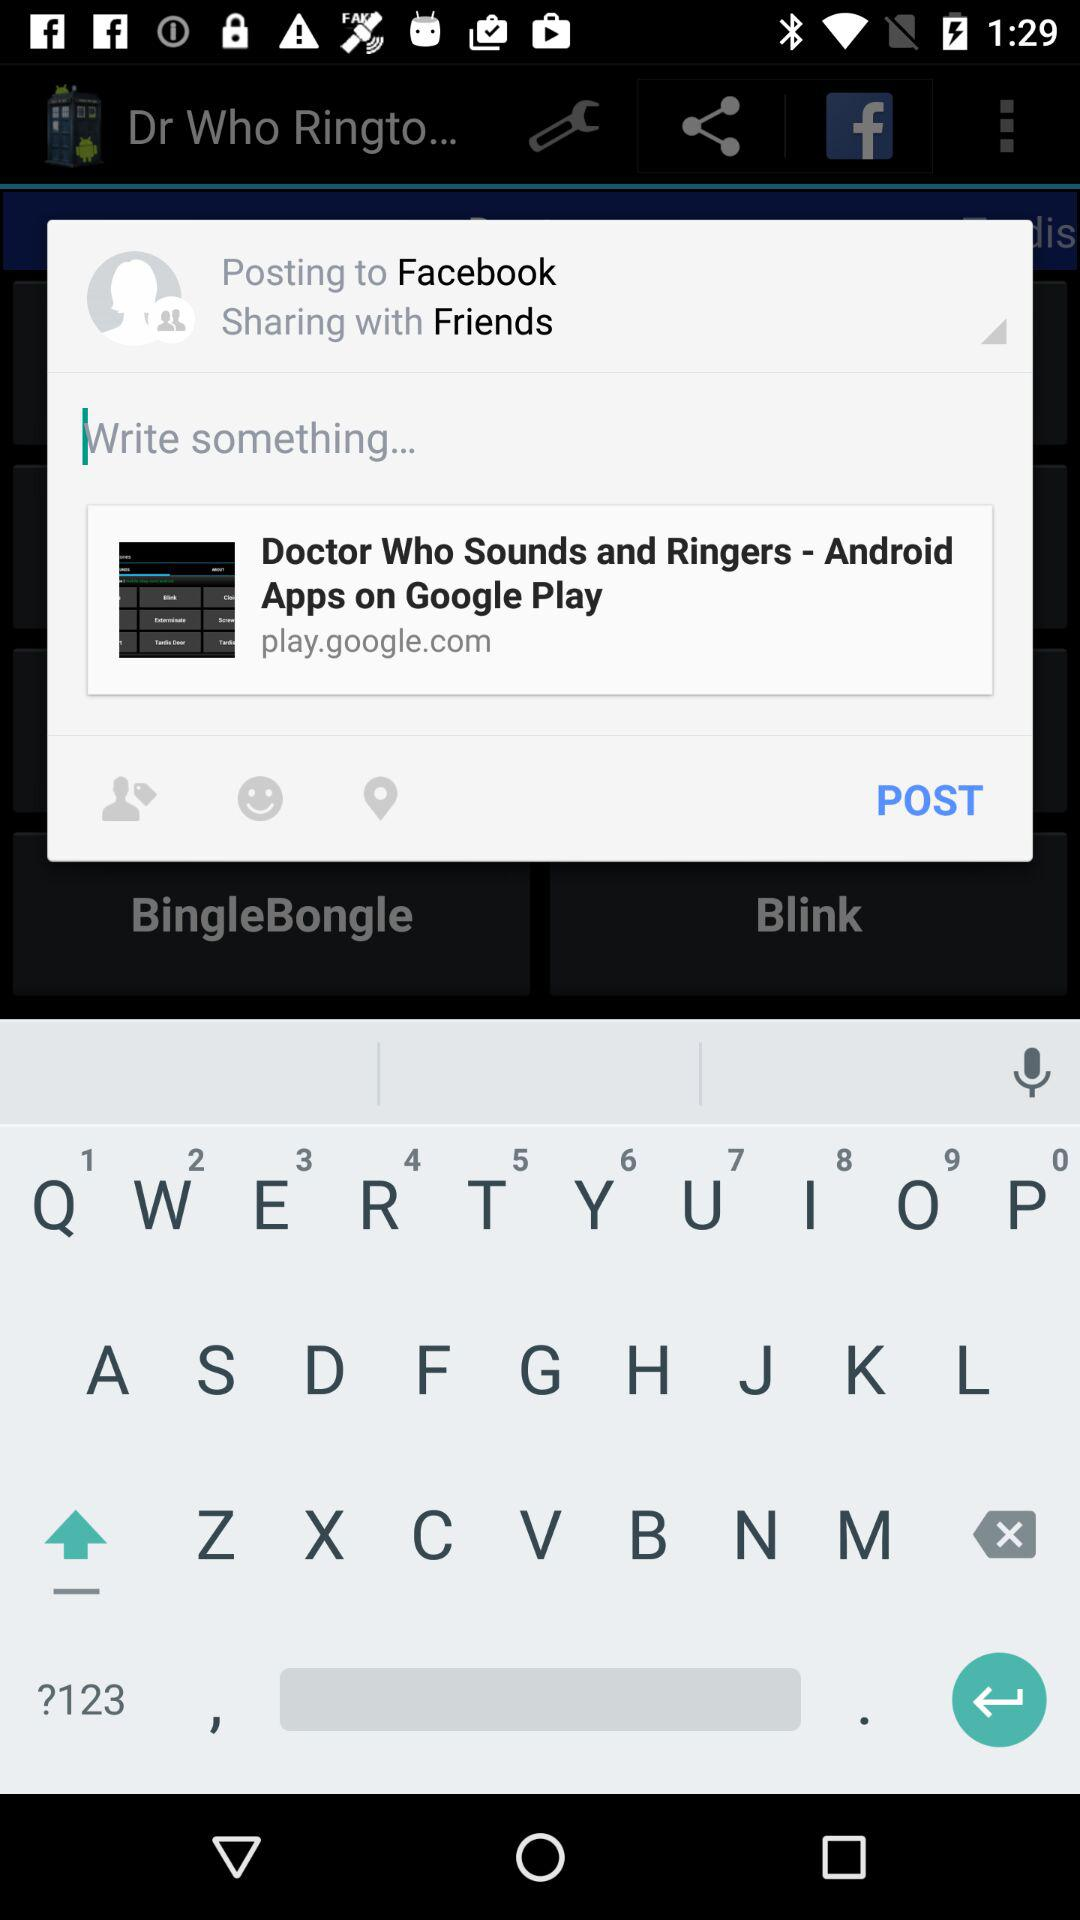What is the version of the application? The version is 5.1.42. 